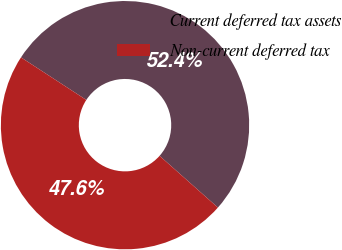Convert chart to OTSL. <chart><loc_0><loc_0><loc_500><loc_500><pie_chart><fcel>Current deferred tax assets<fcel>Non-current deferred tax<nl><fcel>52.36%<fcel>47.64%<nl></chart> 